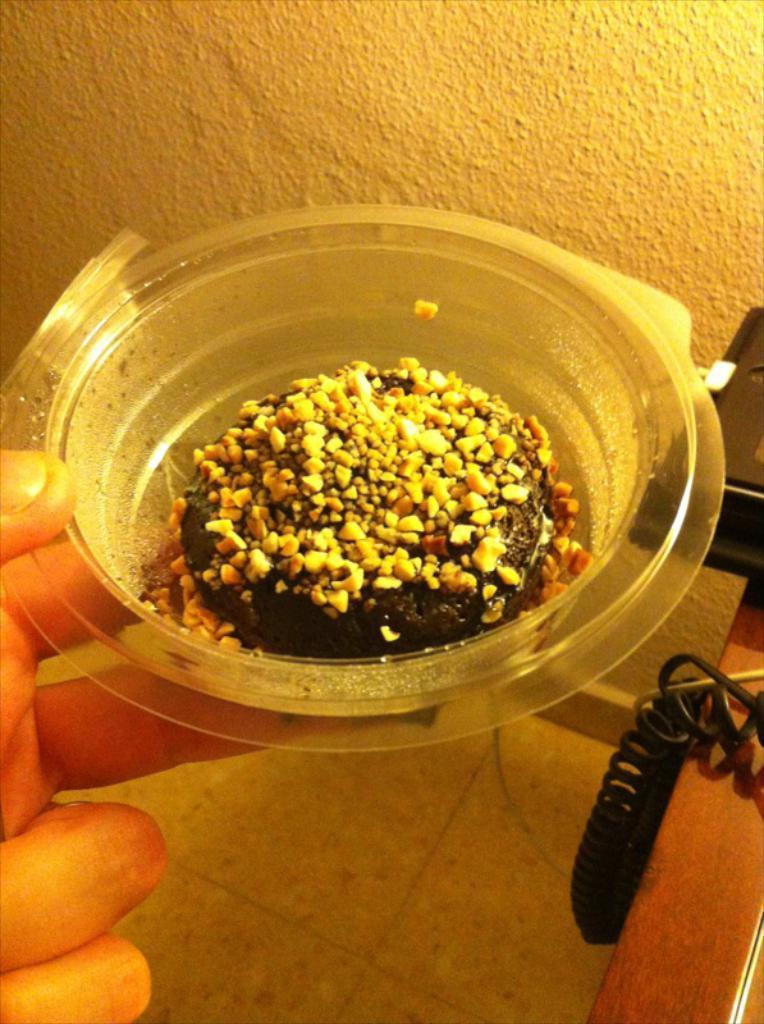Could you give a brief overview of what you see in this image? In this image we can see a human hand is holding a food item in a bowl. On the right side of the image, we can see wires, wooden surface and one black color object. At the bottom of the image, we can see a floor. There is a wall at the top of the image. 